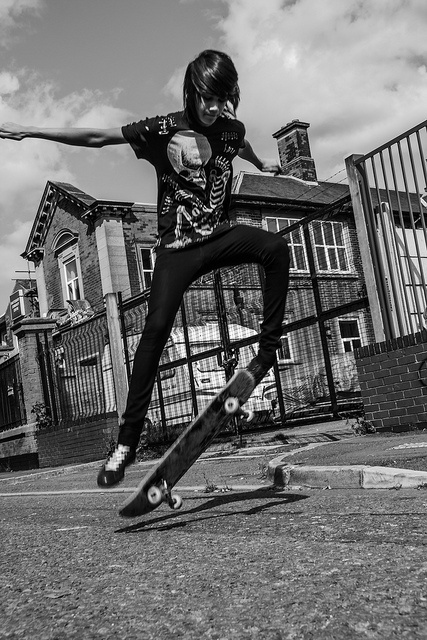Describe the objects in this image and their specific colors. I can see people in darkgray, black, gray, and lightgray tones, truck in darkgray, black, lightgray, and gray tones, and skateboard in darkgray, black, gray, and lightgray tones in this image. 